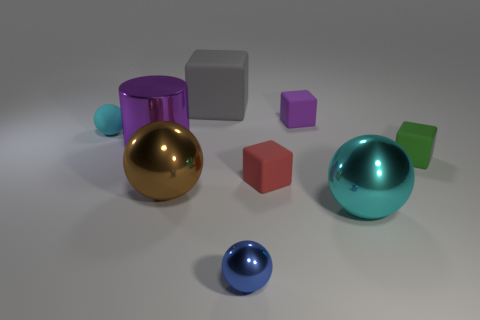Are there any other things that are the same shape as the blue thing? Yes, there is another object with the same spherical shape as the blue ball. It's the larger green object on the right-hand side of the image. Both share a spherical geometry, which is distinct from the other geometric shapes present such as the cubes and the cylinder. 